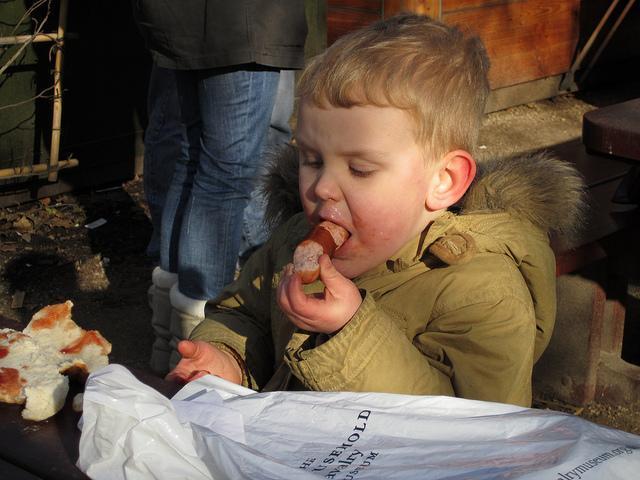How many people are there?
Give a very brief answer. 2. 